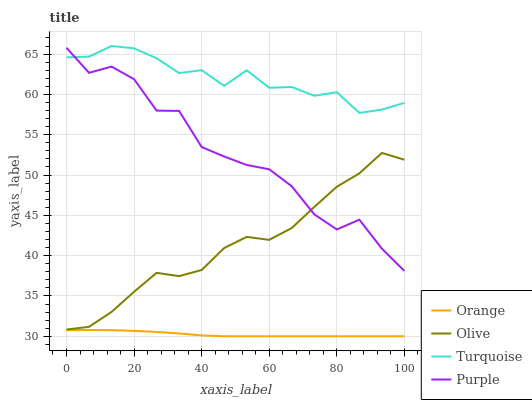Does Orange have the minimum area under the curve?
Answer yes or no. Yes. Does Turquoise have the maximum area under the curve?
Answer yes or no. Yes. Does Olive have the minimum area under the curve?
Answer yes or no. No. Does Olive have the maximum area under the curve?
Answer yes or no. No. Is Orange the smoothest?
Answer yes or no. Yes. Is Purple the roughest?
Answer yes or no. Yes. Is Olive the smoothest?
Answer yes or no. No. Is Olive the roughest?
Answer yes or no. No. Does Orange have the lowest value?
Answer yes or no. Yes. Does Olive have the lowest value?
Answer yes or no. No. Does Turquoise have the highest value?
Answer yes or no. Yes. Does Olive have the highest value?
Answer yes or no. No. Is Orange less than Turquoise?
Answer yes or no. Yes. Is Turquoise greater than Olive?
Answer yes or no. Yes. Does Purple intersect Olive?
Answer yes or no. Yes. Is Purple less than Olive?
Answer yes or no. No. Is Purple greater than Olive?
Answer yes or no. No. Does Orange intersect Turquoise?
Answer yes or no. No. 